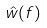Convert formula to latex. <formula><loc_0><loc_0><loc_500><loc_500>\hat { w } ( f )</formula> 